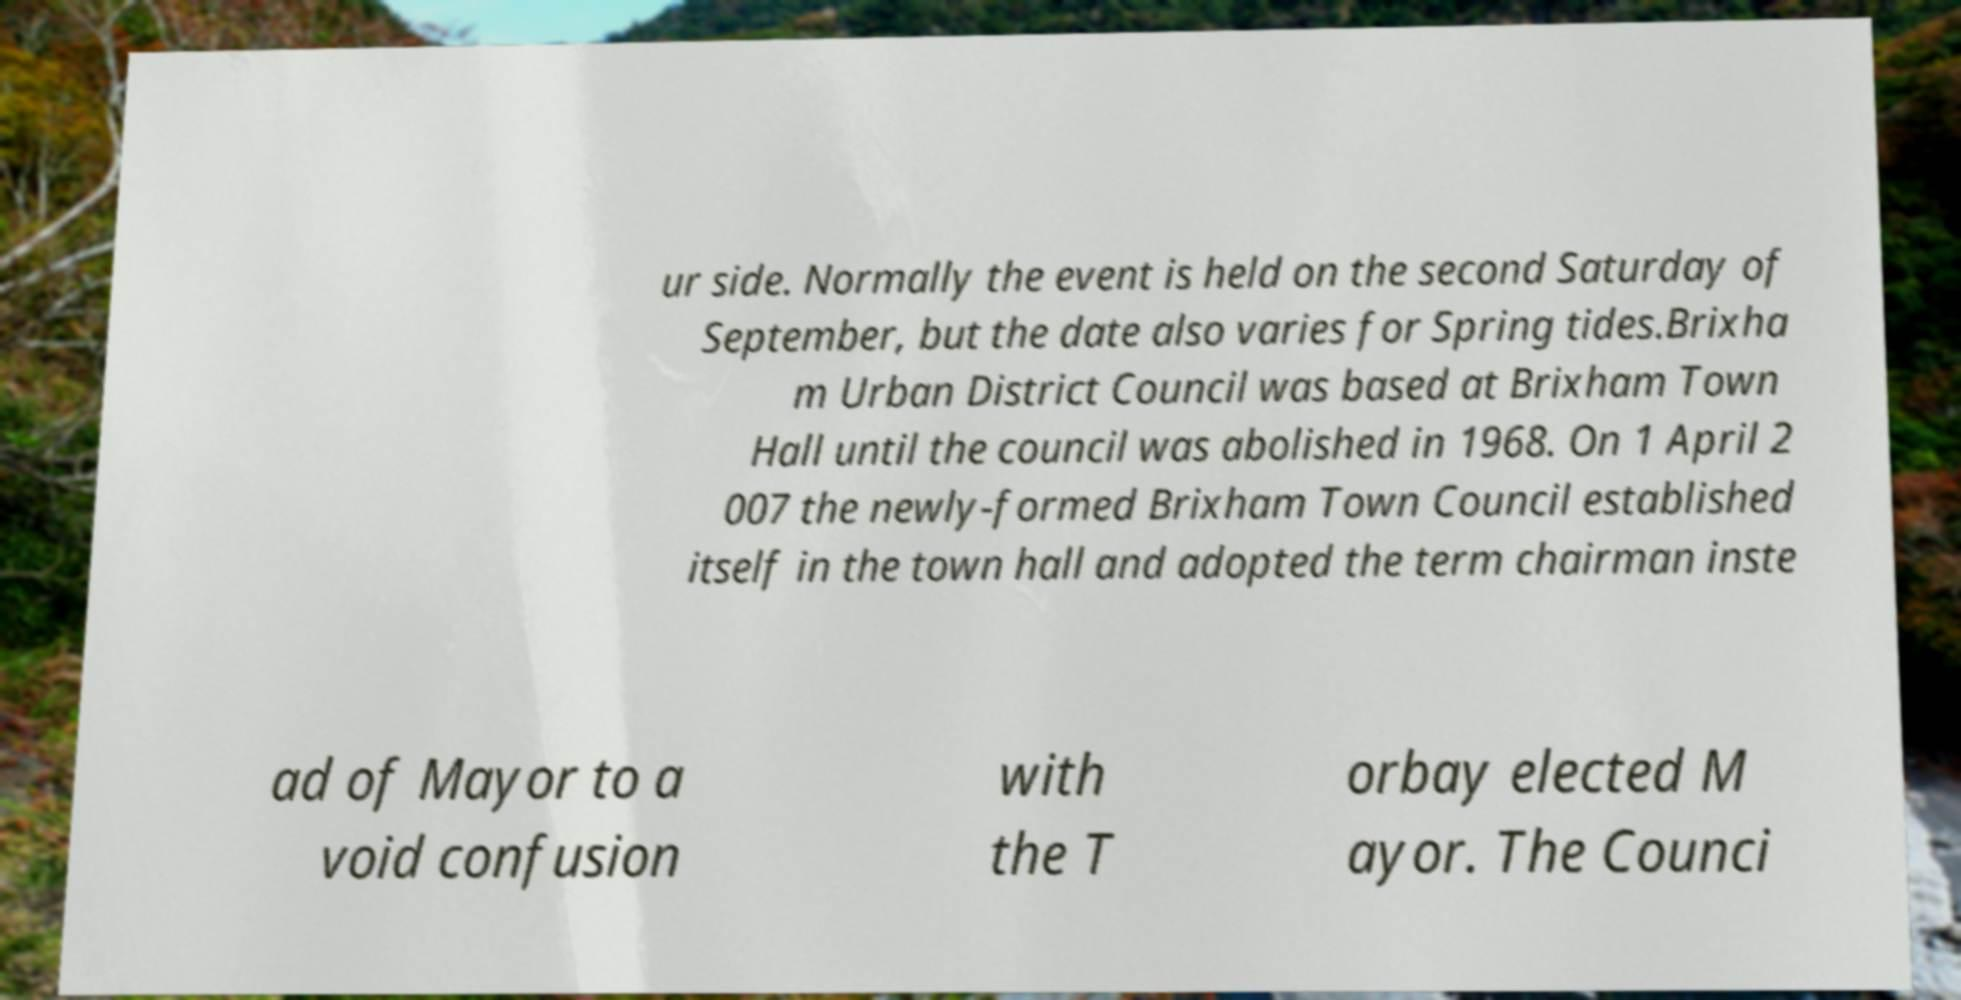What messages or text are displayed in this image? I need them in a readable, typed format. ur side. Normally the event is held on the second Saturday of September, but the date also varies for Spring tides.Brixha m Urban District Council was based at Brixham Town Hall until the council was abolished in 1968. On 1 April 2 007 the newly-formed Brixham Town Council established itself in the town hall and adopted the term chairman inste ad of Mayor to a void confusion with the T orbay elected M ayor. The Counci 